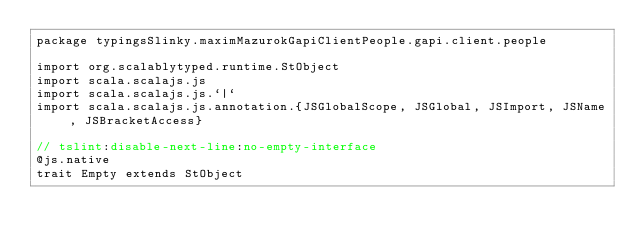Convert code to text. <code><loc_0><loc_0><loc_500><loc_500><_Scala_>package typingsSlinky.maximMazurokGapiClientPeople.gapi.client.people

import org.scalablytyped.runtime.StObject
import scala.scalajs.js
import scala.scalajs.js.`|`
import scala.scalajs.js.annotation.{JSGlobalScope, JSGlobal, JSImport, JSName, JSBracketAccess}

// tslint:disable-next-line:no-empty-interface
@js.native
trait Empty extends StObject
</code> 